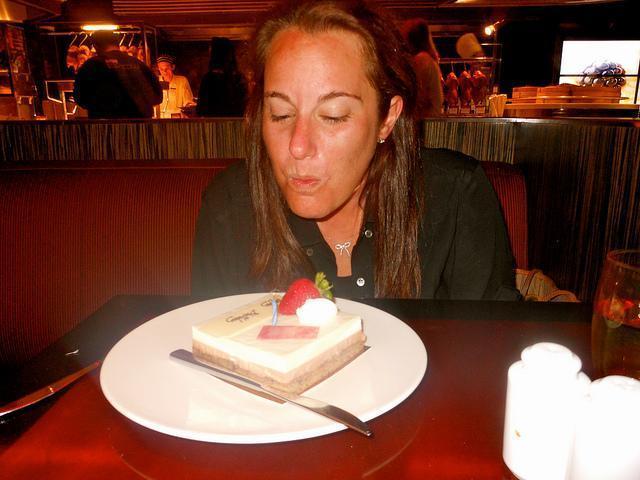How many people are in the picture?
Give a very brief answer. 3. How many knives are in the picture?
Give a very brief answer. 1. 